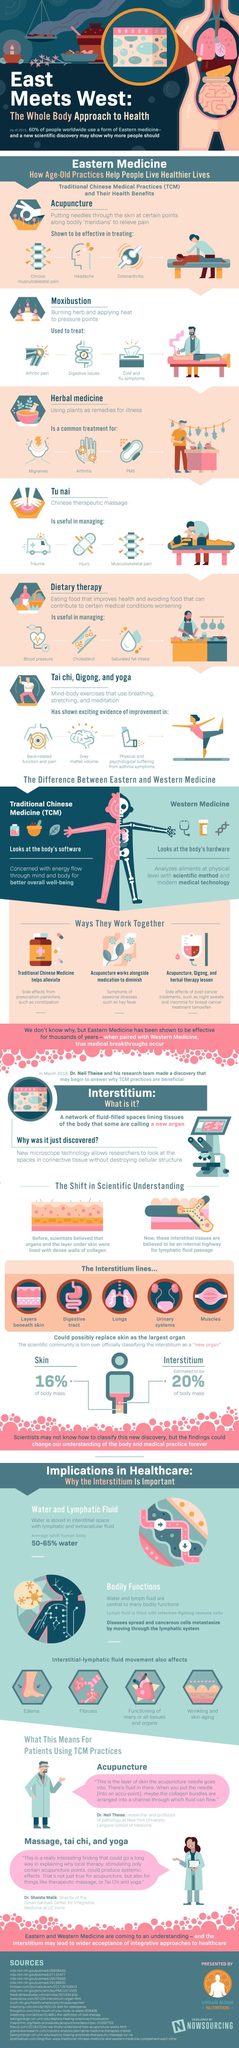List a handful of essential elements in this visual. Moxibustion is a method of treatment that is commonly used to alleviate the symptoms of the common cold and flu. Western medicine is a system of medicine that analyzes ailments at the physical level using modern technology. Acupuncture, Qigong, and herbal therapy have been shown to be effective in reducing the side effects of post-cancer treatments, such as night sweats and insomnia. Acupuncture is a method of treatment that can help alleviate the symptoms of illnesses like hay fever. Traditional Chinese Medicine (TCM) is a system of medicine that is concerned with promoting overall well-being of the mind and body. 